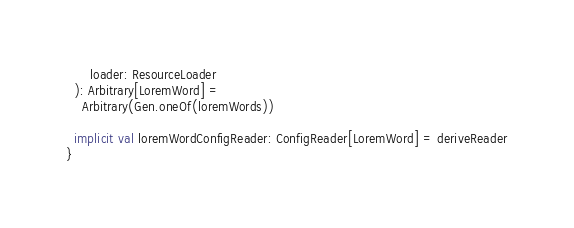<code> <loc_0><loc_0><loc_500><loc_500><_Scala_>      loader: ResourceLoader
  ): Arbitrary[LoremWord] =
    Arbitrary(Gen.oneOf(loremWords))

  implicit val loremWordConfigReader: ConfigReader[LoremWord] = deriveReader
}
</code> 